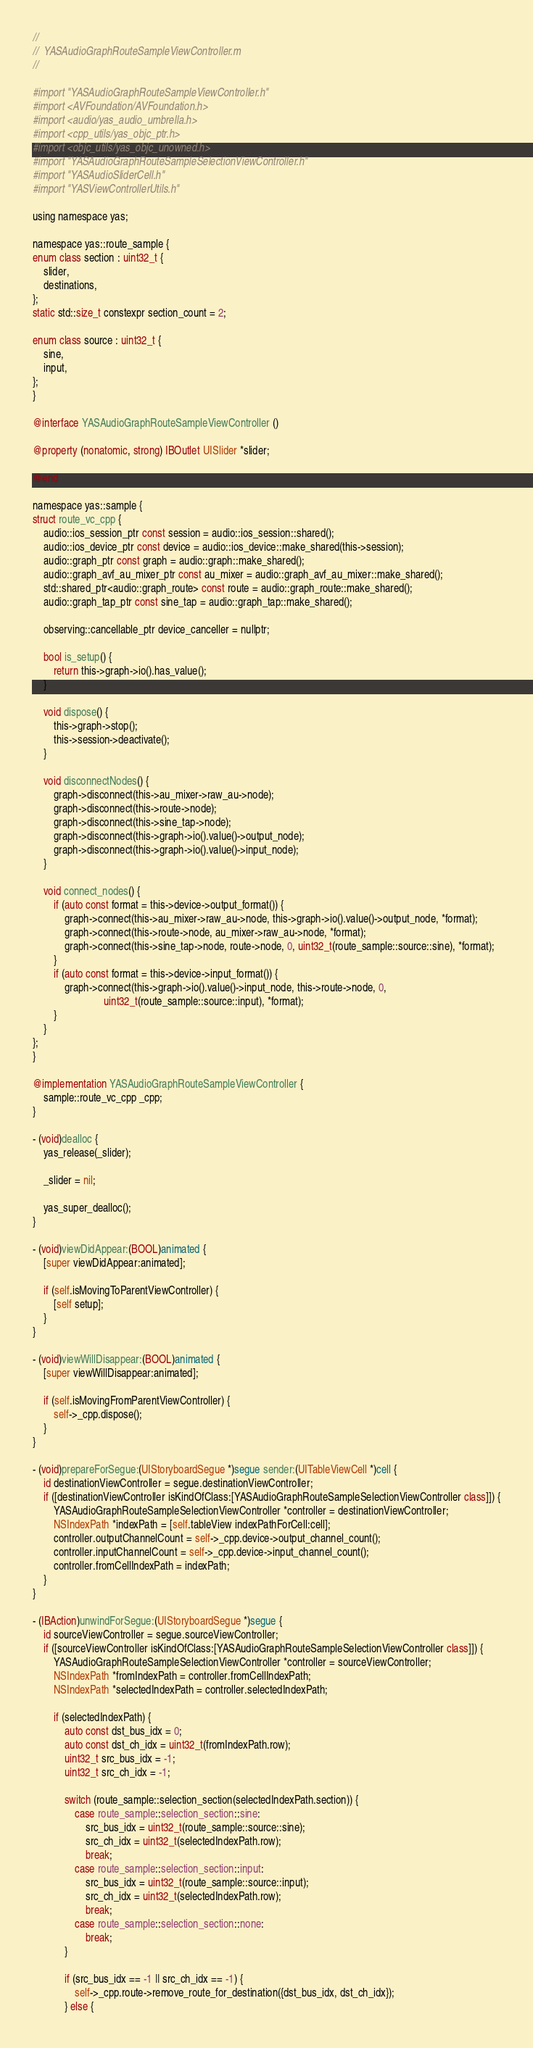<code> <loc_0><loc_0><loc_500><loc_500><_ObjectiveC_>//
//  YASAudioGraphRouteSampleViewController.m
//

#import "YASAudioGraphRouteSampleViewController.h"
#import <AVFoundation/AVFoundation.h>
#import <audio/yas_audio_umbrella.h>
#import <cpp_utils/yas_objc_ptr.h>
#import <objc_utils/yas_objc_unowned.h>
#import "YASAudioGraphRouteSampleSelectionViewController.h"
#import "YASAudioSliderCell.h"
#import "YASViewControllerUtils.h"

using namespace yas;

namespace yas::route_sample {
enum class section : uint32_t {
    slider,
    destinations,
};
static std::size_t constexpr section_count = 2;

enum class source : uint32_t {
    sine,
    input,
};
}

@interface YASAudioGraphRouteSampleViewController ()

@property (nonatomic, strong) IBOutlet UISlider *slider;

@end

namespace yas::sample {
struct route_vc_cpp {
    audio::ios_session_ptr const session = audio::ios_session::shared();
    audio::ios_device_ptr const device = audio::ios_device::make_shared(this->session);
    audio::graph_ptr const graph = audio::graph::make_shared();
    audio::graph_avf_au_mixer_ptr const au_mixer = audio::graph_avf_au_mixer::make_shared();
    std::shared_ptr<audio::graph_route> const route = audio::graph_route::make_shared();
    audio::graph_tap_ptr const sine_tap = audio::graph_tap::make_shared();

    observing::cancellable_ptr device_canceller = nullptr;

    bool is_setup() {
        return this->graph->io().has_value();
    }

    void dispose() {
        this->graph->stop();
        this->session->deactivate();
    }

    void disconnectNodes() {
        graph->disconnect(this->au_mixer->raw_au->node);
        graph->disconnect(this->route->node);
        graph->disconnect(this->sine_tap->node);
        graph->disconnect(this->graph->io().value()->output_node);
        graph->disconnect(this->graph->io().value()->input_node);
    }

    void connect_nodes() {
        if (auto const format = this->device->output_format()) {
            graph->connect(this->au_mixer->raw_au->node, this->graph->io().value()->output_node, *format);
            graph->connect(this->route->node, au_mixer->raw_au->node, *format);
            graph->connect(this->sine_tap->node, route->node, 0, uint32_t(route_sample::source::sine), *format);
        }
        if (auto const format = this->device->input_format()) {
            graph->connect(this->graph->io().value()->input_node, this->route->node, 0,
                           uint32_t(route_sample::source::input), *format);
        }
    }
};
}

@implementation YASAudioGraphRouteSampleViewController {
    sample::route_vc_cpp _cpp;
}

- (void)dealloc {
    yas_release(_slider);

    _slider = nil;

    yas_super_dealloc();
}

- (void)viewDidAppear:(BOOL)animated {
    [super viewDidAppear:animated];

    if (self.isMovingToParentViewController) {
        [self setup];
    }
}

- (void)viewWillDisappear:(BOOL)animated {
    [super viewWillDisappear:animated];

    if (self.isMovingFromParentViewController) {
        self->_cpp.dispose();
    }
}

- (void)prepareForSegue:(UIStoryboardSegue *)segue sender:(UITableViewCell *)cell {
    id destinationViewController = segue.destinationViewController;
    if ([destinationViewController isKindOfClass:[YASAudioGraphRouteSampleSelectionViewController class]]) {
        YASAudioGraphRouteSampleSelectionViewController *controller = destinationViewController;
        NSIndexPath *indexPath = [self.tableView indexPathForCell:cell];
        controller.outputChannelCount = self->_cpp.device->output_channel_count();
        controller.inputChannelCount = self->_cpp.device->input_channel_count();
        controller.fromCellIndexPath = indexPath;
    }
}

- (IBAction)unwindForSegue:(UIStoryboardSegue *)segue {
    id sourceViewController = segue.sourceViewController;
    if ([sourceViewController isKindOfClass:[YASAudioGraphRouteSampleSelectionViewController class]]) {
        YASAudioGraphRouteSampleSelectionViewController *controller = sourceViewController;
        NSIndexPath *fromIndexPath = controller.fromCellIndexPath;
        NSIndexPath *selectedIndexPath = controller.selectedIndexPath;

        if (selectedIndexPath) {
            auto const dst_bus_idx = 0;
            auto const dst_ch_idx = uint32_t(fromIndexPath.row);
            uint32_t src_bus_idx = -1;
            uint32_t src_ch_idx = -1;

            switch (route_sample::selection_section(selectedIndexPath.section)) {
                case route_sample::selection_section::sine:
                    src_bus_idx = uint32_t(route_sample::source::sine);
                    src_ch_idx = uint32_t(selectedIndexPath.row);
                    break;
                case route_sample::selection_section::input:
                    src_bus_idx = uint32_t(route_sample::source::input);
                    src_ch_idx = uint32_t(selectedIndexPath.row);
                    break;
                case route_sample::selection_section::none:
                    break;
            }

            if (src_bus_idx == -1 || src_ch_idx == -1) {
                self->_cpp.route->remove_route_for_destination({dst_bus_idx, dst_ch_idx});
            } else {</code> 